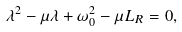<formula> <loc_0><loc_0><loc_500><loc_500>\lambda ^ { 2 } - \mu \lambda + \omega _ { 0 } ^ { 2 } - \mu L _ { R } = 0 ,</formula> 